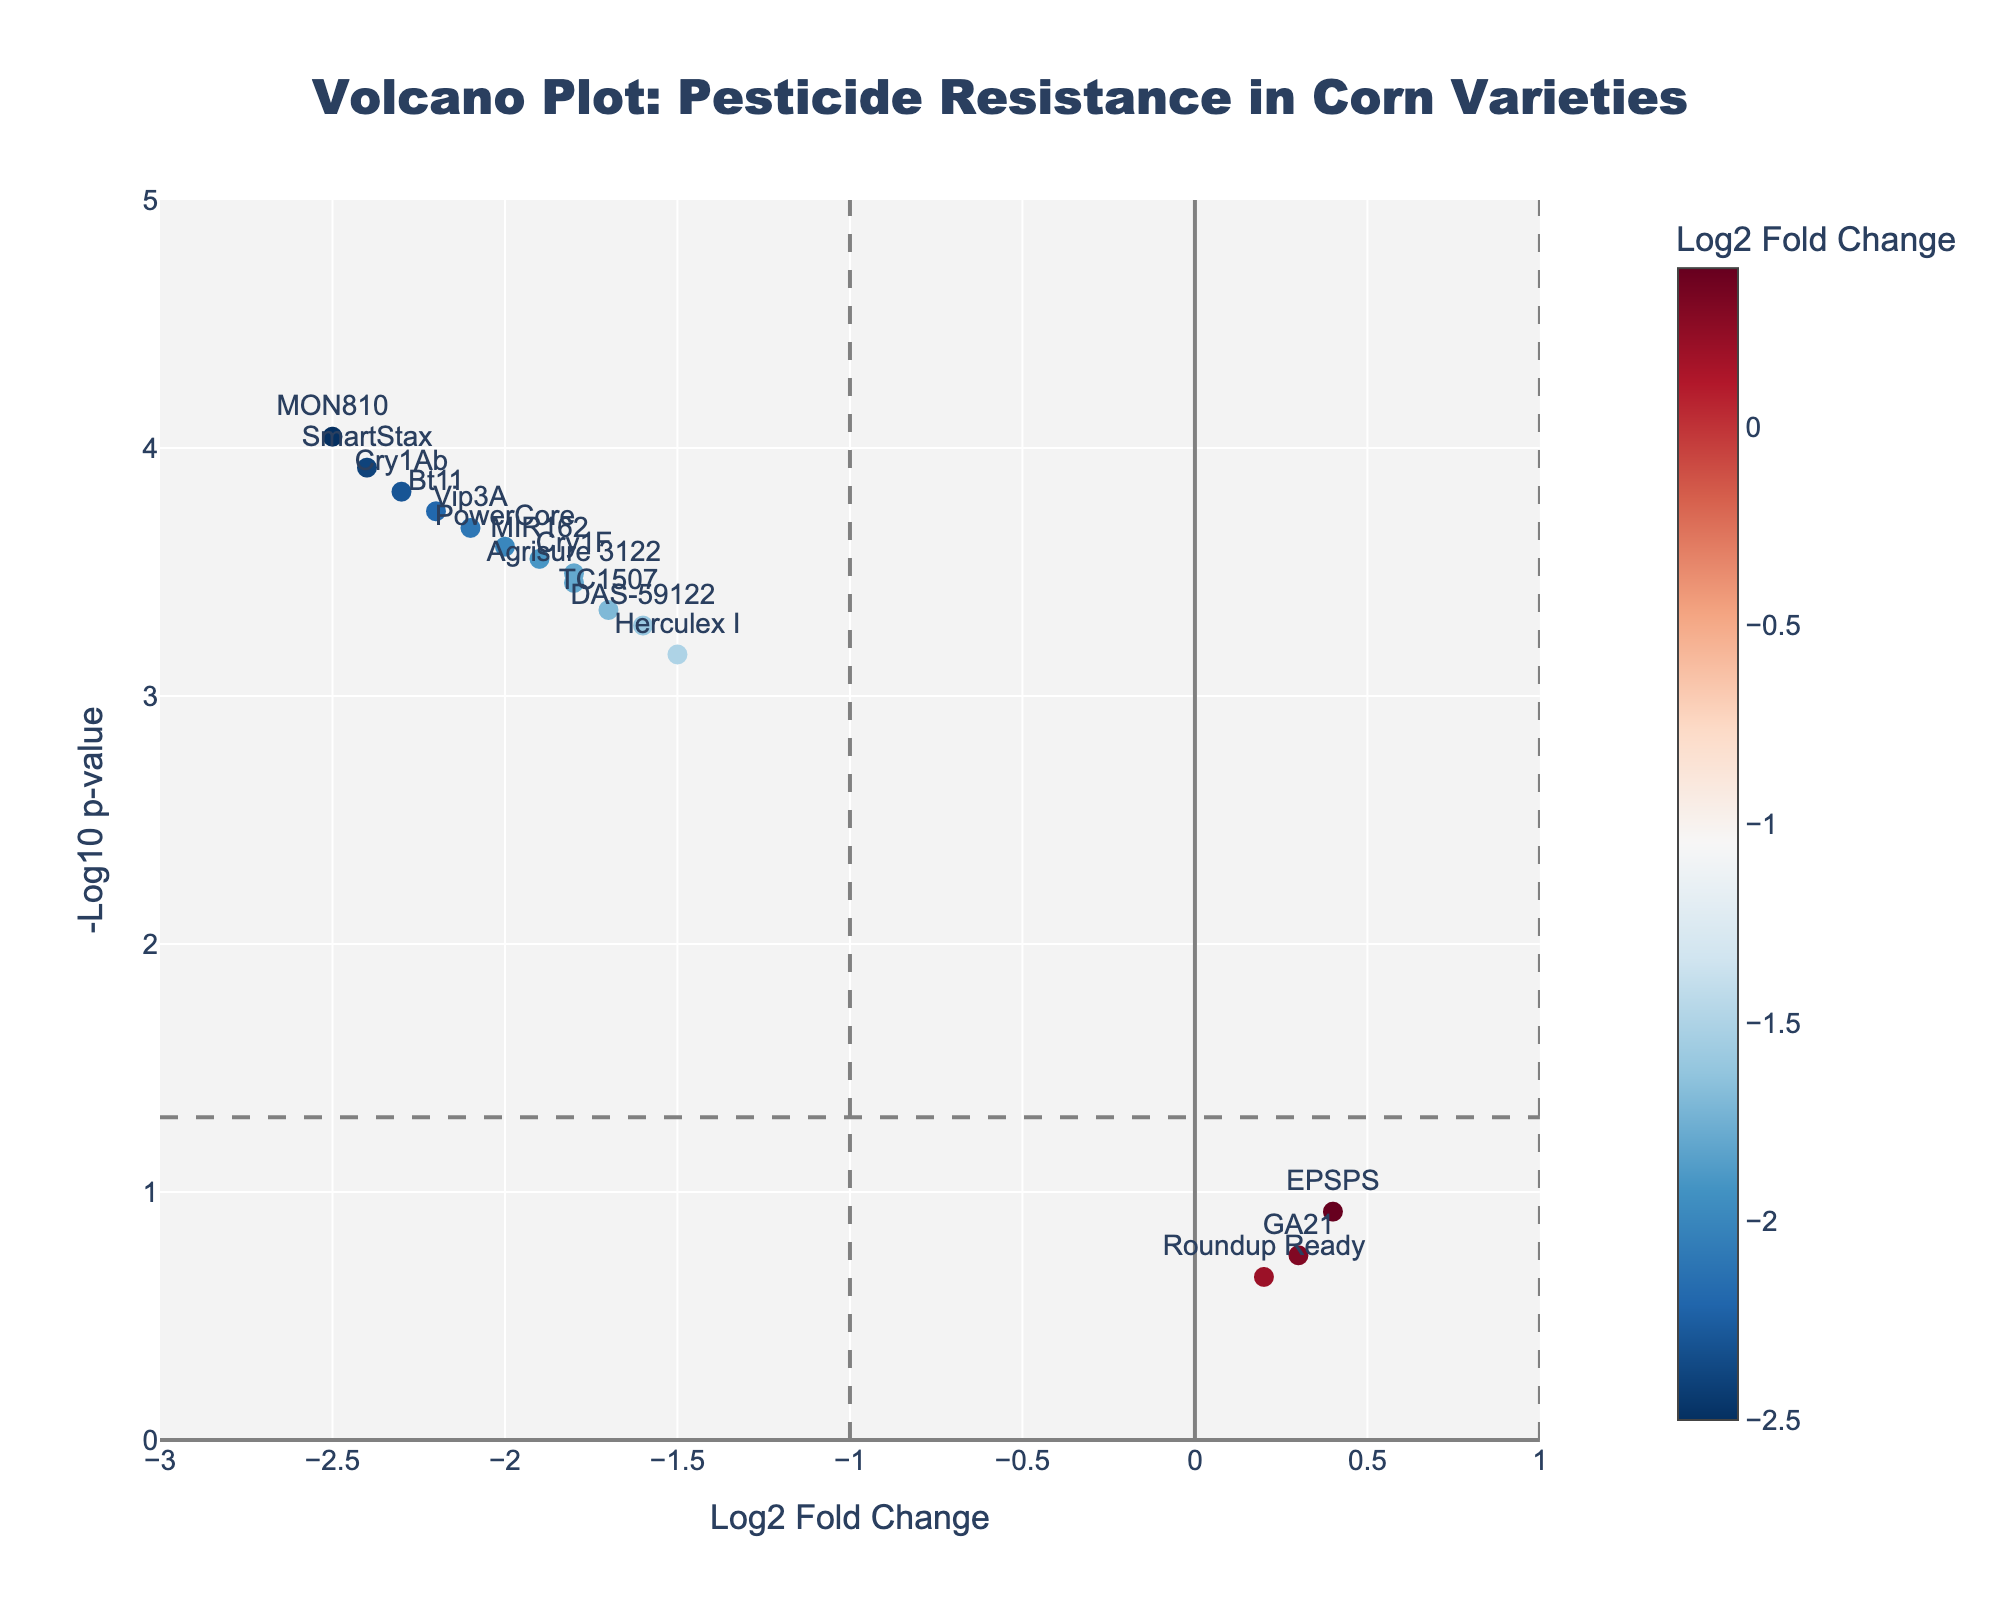What is the title of the figure? The title is typically placed at the top of the figure. Here, it reads "Volcano Plot: Pesticide Resistance in Corn Varieties".
Answer: Volcano Plot: Pesticide Resistance in Corn Varieties What do the axes represent in the Volcano Plot? The x-axis represents the Log2 Fold Change, while the y-axis represents the -Log10 p-value. These labels are directly visible on the respective axes of the plot.
Answer: The x-axis shows the Log2 Fold Change and the y-axis shows the -Log10 p-value How many data points are displayed in the plot? Each gene listed in the data is represented as a point on the plot. By counting all the points, there are 14 in total.
Answer: 14 Which gene has the highest -Log10 p-value? The highest -Log10 p-value can be determined by looking at the tallest point on the y-axis. This is the gene 'MON810'.
Answer: MON810 Which gene has the highest Log2 Fold Change? The highest Log2 Fold Change is represented by the point farthest to the right on the x-axis. This gene is 'EPSPS'.
Answer: EPSPS Which gene has the lowest Log2 Fold Change? The lowest Log2 Fold Change is represented by the point farthest to the left on the x-axis. This gene is 'MON810'.
Answer: MON810 How many genes have a Log2 Fold Change less than -1 and a -Log10 p-value greater than 1.3? A Log2 Fold Change less than -1 means points are to the left of -1 on the x-axis. A -Log10 p-value greater than 1.3 indicates points above the horizontal line y = 1.3. By counting such points, there are 12.
Answer: 12 What is the general trend observed for genetically modified corn varieties concerning pesticide resistance compared to conventional ones? The general trend can be observed by seeing that most points (genes of genetically modified corn varieties) are on the left side of the plot with higher -Log10 p-values, indicating a reduction in pest resistance due to genetic modification.
Answer: Reduced pest resistance Which genes fall outside the region defined by Log2 Fold Change between -1 and 1, and a p-value less than 0.05? Points with Log2 Fold Change outside -1 to 1 are those not between the two vertical dashed lines, and with a p-value less than 0.05 corresponds to the points above the horizontal dashed line (since -Log10(0.05) ≈ 1.3). These genes are 'Cry1Ab', 'Cry1F', 'Vip3A', 'MON810', 'Bt11', 'MIR162', 'TC1507', 'DAS-59122', 'Herculex I', 'SmartStax', 'PowerCore', and 'Agrisure 3122'.
Answer: Cry1Ab, Cry1F, Vip3A, MON810, Bt11, MIR162, TC1507, DAS-59122, Herculex I, SmartStax, PowerCore, Agrisure 3122 Which genes have a p-value less than 0.001? A p-value less than 0.001 corresponds to -Log10(p-value) greater than or equal to 3. By looking for points above y=3, these genes are 'Cry1Ab', 'Vip3A', 'MON810', 'Bt11', 'SmartStax'.
Answer: Cry1Ab, Vip3A, MON810, Bt11, SmartStax 